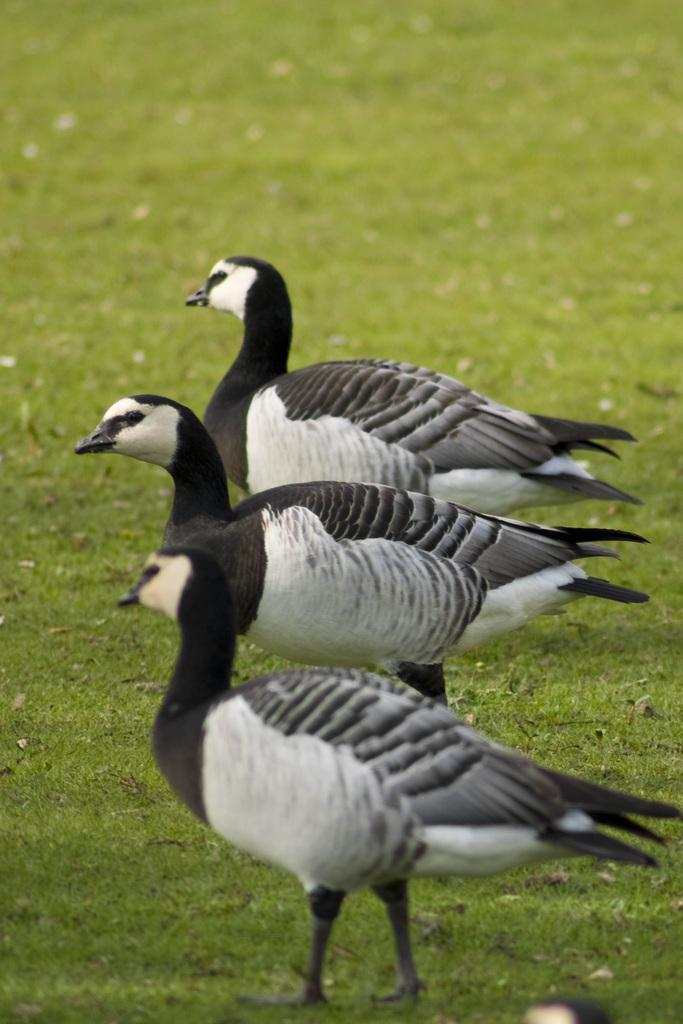How many birds can be seen in the image? There are three birds in the image. What is the surface on which the birds are standing? The birds are standing on the grassland. What type of chairs can be seen in the image? There are no chairs present in the image. What color is the dress worn by the bird in the image? Birds do not wear dresses, and there is no bird wearing a dress in the image. 